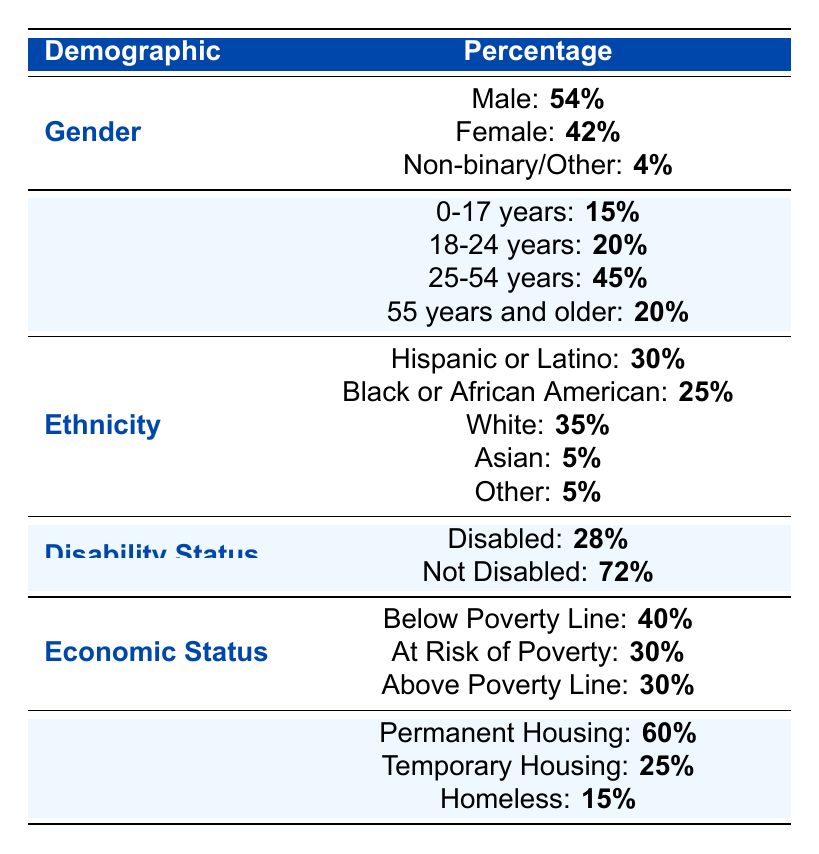What percentage of war survivors are male? The table shows that **54%** of the war survivors are in the male category under the Gender demographic.
Answer: 54% What is the percentage of war survivors aged 55 years and older? The Age Range demographic indicates that **20%** of war survivors fall within the 55 years and older category.
Answer: 20% Which ethnic group has the highest percentage among war survivors? The Ethnicity demographic shows that **White** war survivors have the highest percentage at **35%**.
Answer: White Are there more disabled or not disabled war survivors? The Disability Status demographic indicates that **72%** are not disabled, while **28%** are disabled, so there are more not disabled survivors.
Answer: No What percentage of war survivors are living in temporary housing? The Living Situation section lists **25%** of war survivors living in temporary housing.
Answer: 25% What is the total percentage of war survivors that are either at risk of poverty or below the poverty line? The Economic Status shows that **40%** are below the poverty line and **30%** are at risk of poverty. Adding these gives **40% + 30% = 70%**.
Answer: 70% If you combine the percentages of both female and non-binary/other survivors, what total percentage do you get? The table indicates **42%** are female and **4%** are non-binary/other. Adding these gives **42% + 4% = 46%**.
Answer: 46% What percentage of war survivors are either homeless or living in temporary housing? The Living Situation shows **15%** are homeless and **25%** are in temporary housing. Therefore, **15% + 25% = 40%** are either homeless or in temporary housing.
Answer: 40% Is it true that the majority of war survivors are below the poverty line? Yes, **40%** of war survivors fall below the poverty line, which is more than any other economic status category.
Answer: Yes What is the percentage difference between the age groups 25-54 years and 0-17 years? The Age Range shows that **45%** are in the 25-54 years category and **15%** in the 0-17 years category. The difference is **45% - 15% = 30%**.
Answer: 30% 